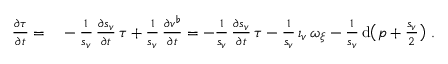Convert formula to latex. <formula><loc_0><loc_0><loc_500><loc_500>\begin{array} { r l } { \frac { \partial \tau } { \partial t } = } & - \frac { 1 } { s _ { v } } \, \frac { \partial s _ { v } } { \partial t } \, \tau + \frac { 1 } { s _ { v } } \, \frac { \partial v ^ { \flat } } { \partial t } = - \frac { 1 } { s _ { v } } \, \frac { \partial s _ { v } } { \partial t } \, \tau - \frac { 1 } { s _ { v } } \, \iota _ { v } \, \omega _ { \xi } - \frac { 1 } { s _ { v } } \, d \left ( p + \frac { s _ { v } } { 2 } \right ) \ . } \end{array}</formula> 